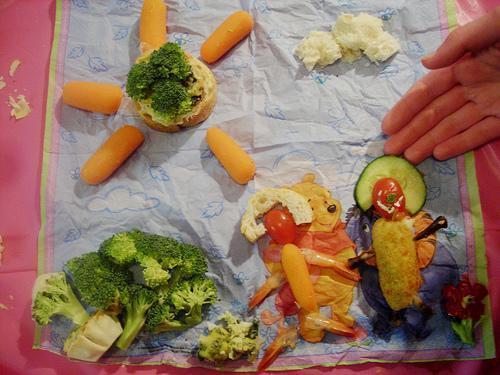How many carrots are on top of the cartoon image?
Give a very brief answer. 1. 